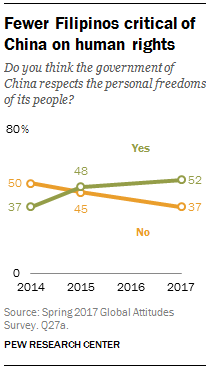Draw attention to some important aspects in this diagram. In the year that the two lines crossed, the average of the data was [2015, 46.5]. The light green line in the image denotes the "Which category" category. 